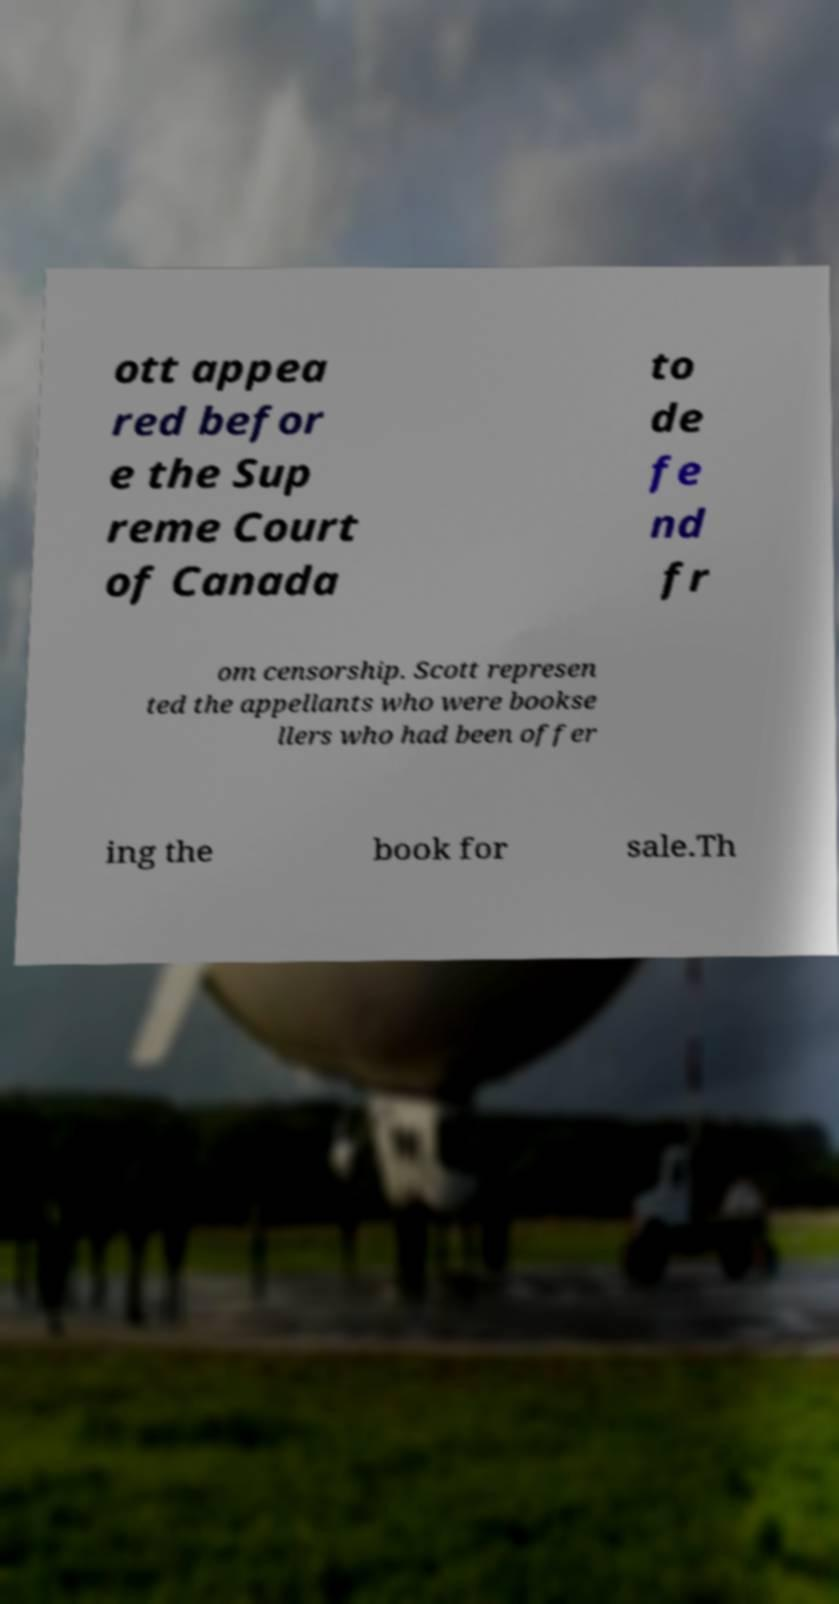Could you extract and type out the text from this image? ott appea red befor e the Sup reme Court of Canada to de fe nd fr om censorship. Scott represen ted the appellants who were bookse llers who had been offer ing the book for sale.Th 